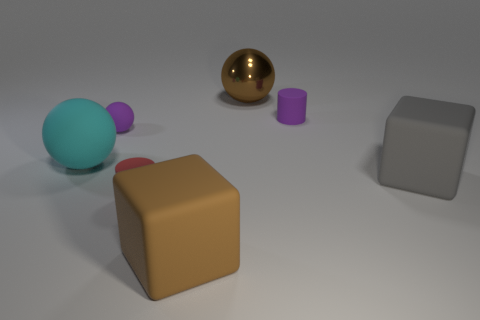How many other things are the same size as the brown shiny ball?
Your response must be concise. 3. There is a big rubber object in front of the big gray thing; is it the same shape as the large matte object that is on the right side of the tiny purple cylinder?
Provide a succinct answer. Yes. How many big rubber objects are there?
Give a very brief answer. 3. What is the color of the sphere that is the same size as the red matte thing?
Keep it short and to the point. Purple. Is the small cylinder that is in front of the purple ball made of the same material as the large gray thing that is in front of the purple rubber cylinder?
Keep it short and to the point. Yes. What is the size of the cylinder behind the cylinder in front of the cyan thing?
Your response must be concise. Small. There is a small purple object that is on the left side of the shiny object; what is its material?
Provide a short and direct response. Rubber. How many things are either things that are in front of the gray cube or tiny objects that are on the left side of the tiny red matte thing?
Provide a succinct answer. 3. There is a tiny purple thing that is the same shape as the big cyan thing; what material is it?
Give a very brief answer. Rubber. There is a rubber cube on the left side of the purple cylinder; is its color the same as the large sphere behind the large cyan matte thing?
Give a very brief answer. Yes. 